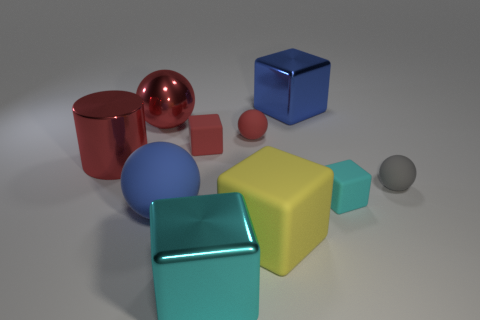Are there more small blue blocks than matte cubes?
Your response must be concise. No. What is the size of the red metallic sphere?
Your answer should be very brief. Large. How many other objects are the same color as the large shiny ball?
Your response must be concise. 3. Is the material of the big ball that is behind the large metal cylinder the same as the large yellow block?
Your answer should be compact. No. Is the number of small cyan rubber objects that are left of the big cyan metal object less than the number of large blue shiny cubes in front of the tiny red matte block?
Your answer should be very brief. No. What number of other things are made of the same material as the yellow block?
Offer a very short reply. 5. What material is the other block that is the same size as the cyan matte block?
Keep it short and to the point. Rubber. Are there fewer blue rubber things behind the large metallic cylinder than red shiny cylinders?
Your answer should be very brief. Yes. What shape is the red rubber object in front of the tiny red ball in front of the large cube right of the yellow thing?
Your answer should be very brief. Cube. What size is the metallic thing that is in front of the small gray thing?
Offer a terse response. Large. 